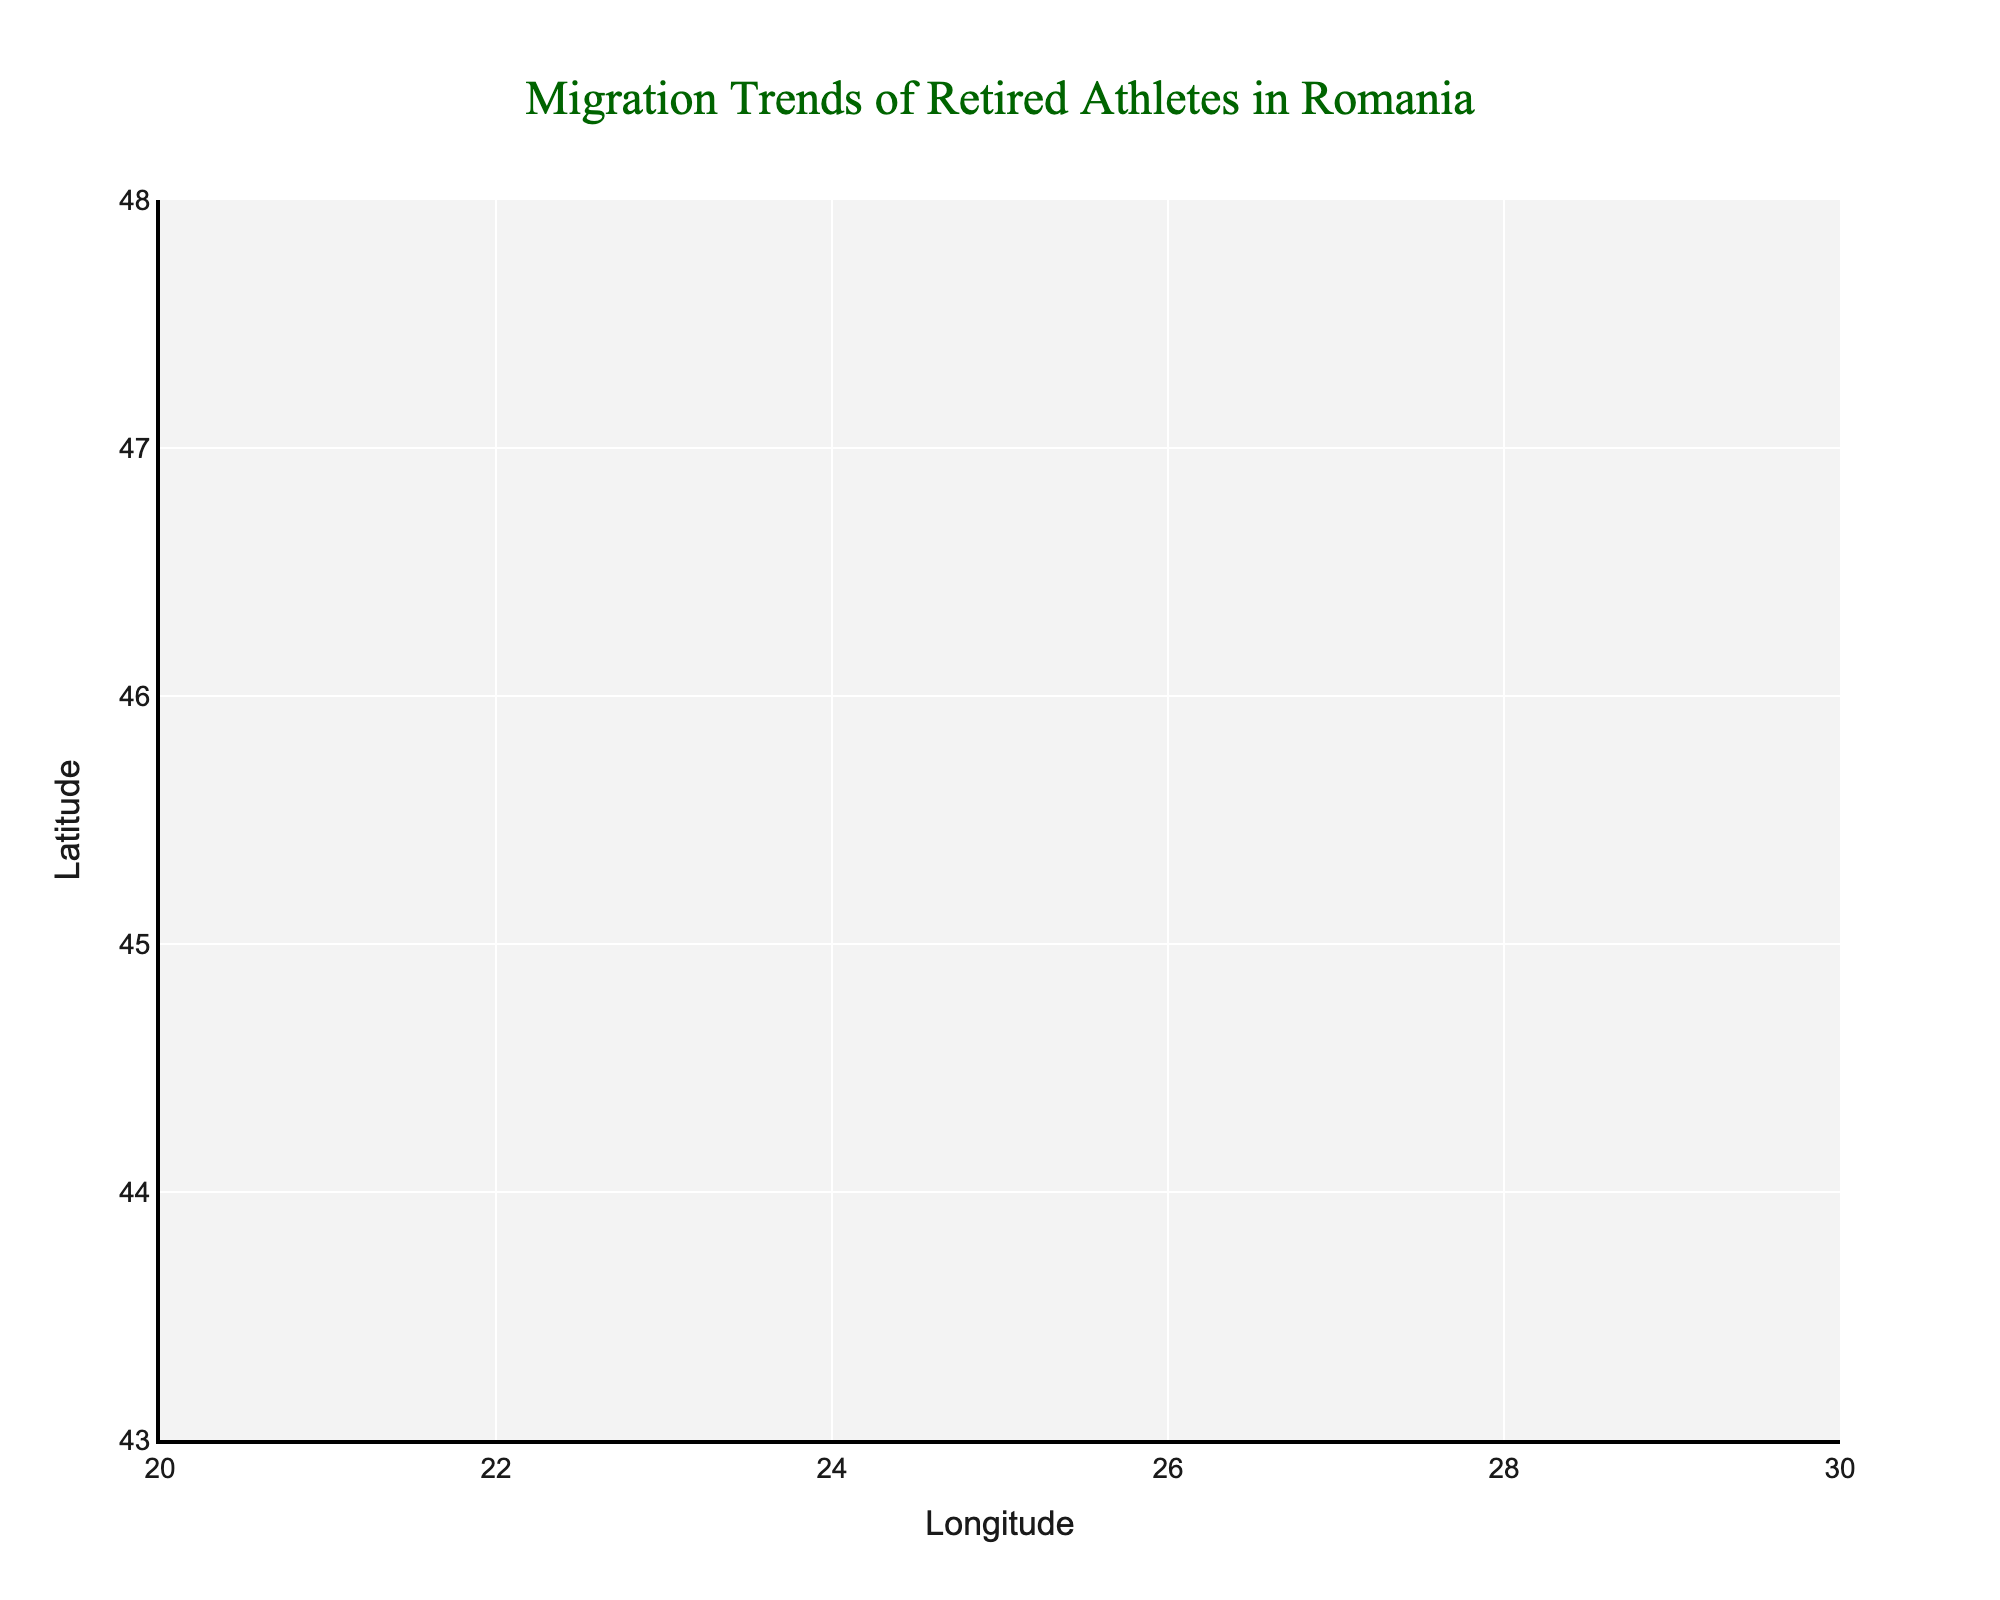How many cities are represented in the figure? There are 10 data points in the quiver plot, and each data point is labeled with a city name. Counting these labels gives 10 cities.
Answer: 10 What is the title of the plot? The title of the plot is located at the top and reads "Migration Trends of Retired Athletes in Romania".
Answer: Migration Trends of Retired Athletes in Romania Which city shows the most significant migration towards the north? To determine this, we look for the city with the largest positive vertical component (v). Timișoara has the largest positive v value of 0.5.
Answer: Timișoara What are the coordinates of Pitești in the figure? The city markers display the coordinates, showing Pitești at (45.10, 24.36).
Answer: (45.10, 24.36) Which city has the largest outbound migration towards the southeast? We look for the city with the most negative u and v components combined, which is Constanța with values (-0.3, -0.3).
Answer: Constanța Is the migration trend for Brașov generally towards a single direction? For Brașov, the u component is -0.2 and the v component is 0.3. This indicates a southwest-to-northeast migration trend, confirming a single general direction of migration.
Answer: Yes Which city has a migration vector directed mostly to the west? By checking for negative u values, Bacău has the most negative u value of -0.4, indicating a strong westward migration.
Answer: Bacău Compare the migration trends between Iași and Cluj-Napoca. Iași has a vector (u=0.3, v=0.2) directed towards the northeast, while Cluj-Napoca has a vector (u=0.4, v=-0.2) directed towards the east-southeast. Thus, Iași's trend is more northerly compared to Cluj-Napoca.
Answer: Iași trends more northerly What is the range of latitudes displayed on the y-axis? The y-axis range can be inferred from the plot's labels, which show it spans approximately from 43 to 48 degrees latitude.
Answer: 43 to 48 